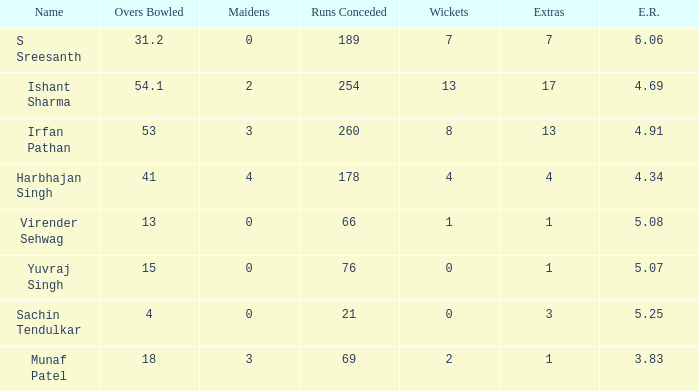Name the wickets for overs bowled being 15 0.0. 